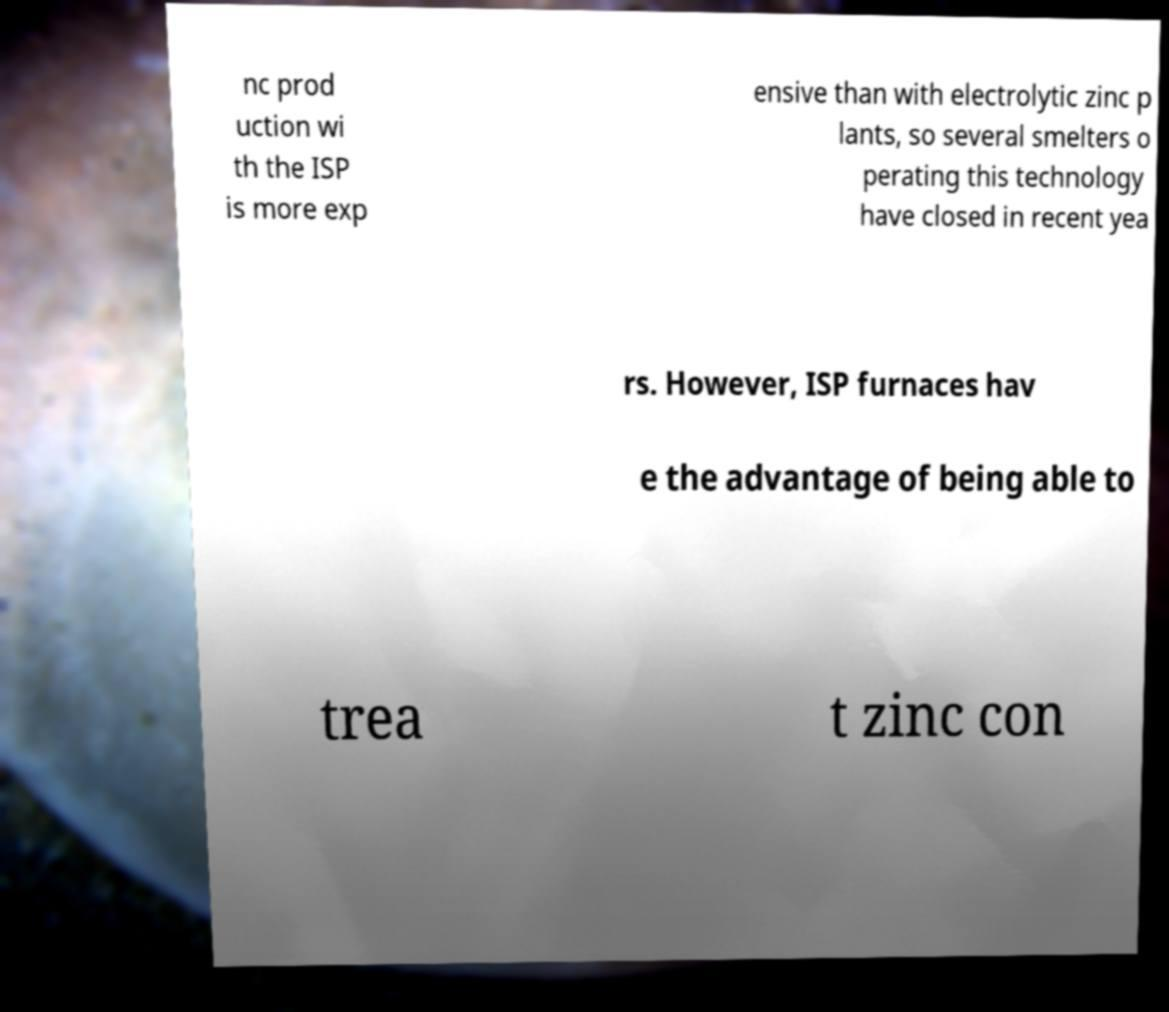Could you extract and type out the text from this image? nc prod uction wi th the ISP is more exp ensive than with electrolytic zinc p lants, so several smelters o perating this technology have closed in recent yea rs. However, ISP furnaces hav e the advantage of being able to trea t zinc con 